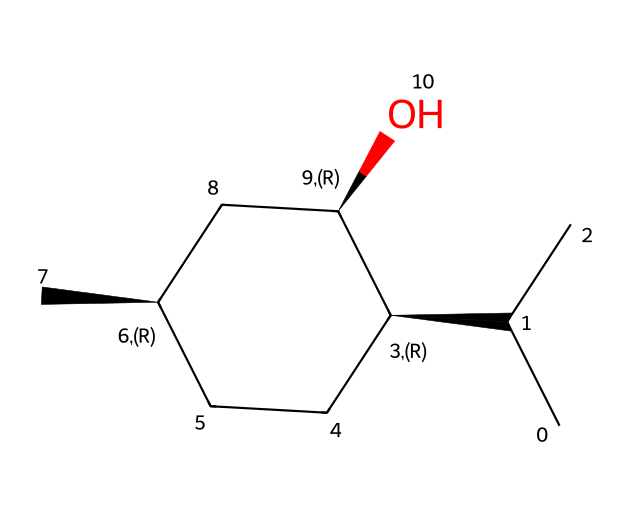What is the molecular formula of menthol? The SMILES representation indicates the presence of carbon (C), hydrogen (H), and oxygen (O) atoms. By counting the carbons (10), hydrogens (20), and oxygens (1) in the molecular structure, the molecular formula can be deduced as C10H20O.
Answer: C10H20O How many chiral centers are in menthol? Looking at the SMILES structure, it contains two stereogenic centers (indicated by @ symbols). Each chirality center corresponds to a carbon atom that is bonded to four different groups. Thus, menthol has two chiral centers.
Answer: 2 What type of solid is menthol? Menthol typically crystallizes in the form of a monoclinic solid structure, which is often observed in organic molecules with similar configurations. The arrangement of menthol in the solid state displays a well-organized, crystalline structure.
Answer: crystalline What is the primary functional group in menthol? By examining the structure, one can identify the hydroxyl (-OH) group attached to a carbon atom, which denotes its classification as an alcohol. The presence of this functional group is the defining characteristic of menthol.
Answer: alcohol What characteristic property of menthol causes its cooling sensation? The cooling sensation is primarily due to the interaction of menthol with the TRPM8 receptor, which is activated upon contact, creating a perception of coolness. This molecular interaction is essential for its sensory properties.
Answer: TRPM8 receptor How many total atoms are present in the molecular structure of menthol? By summing the individual contributions of each type of atom in the molecular formula (C10 + H20 + O1), the total number of atoms can be calculated as 31.
Answer: 31 What is the solubility characteristic of menthol? Menthol is known to be soluble in organic solvents and has limited solubility in water due to its hydrophobic carbon chain coupled with a hydrophilic hydroxyl group. Its solubility profile reflects the balance of these properties.
Answer: partially soluble 